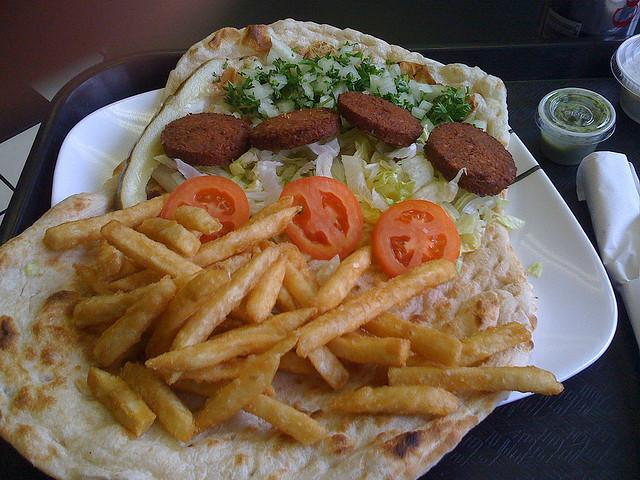Are there noodles on the plate?
Keep it brief. No. What kind of chips are on the plate?
Answer briefly. French fries. What genre of food is this?
Concise answer only. Greek. What meat is in the picture?
Quick response, please. Sausage. How many tomatoes are there?
Concise answer only. 3. Are those regular fries or sweet potato fries?
Short answer required. Regular. Is the sandwich vegetarian?
Be succinct. No. What kind of meat is on the food?
Be succinct. Sausage. Can we eat this now?
Write a very short answer. Yes. What is the red thing?
Short answer required. Tomato. 